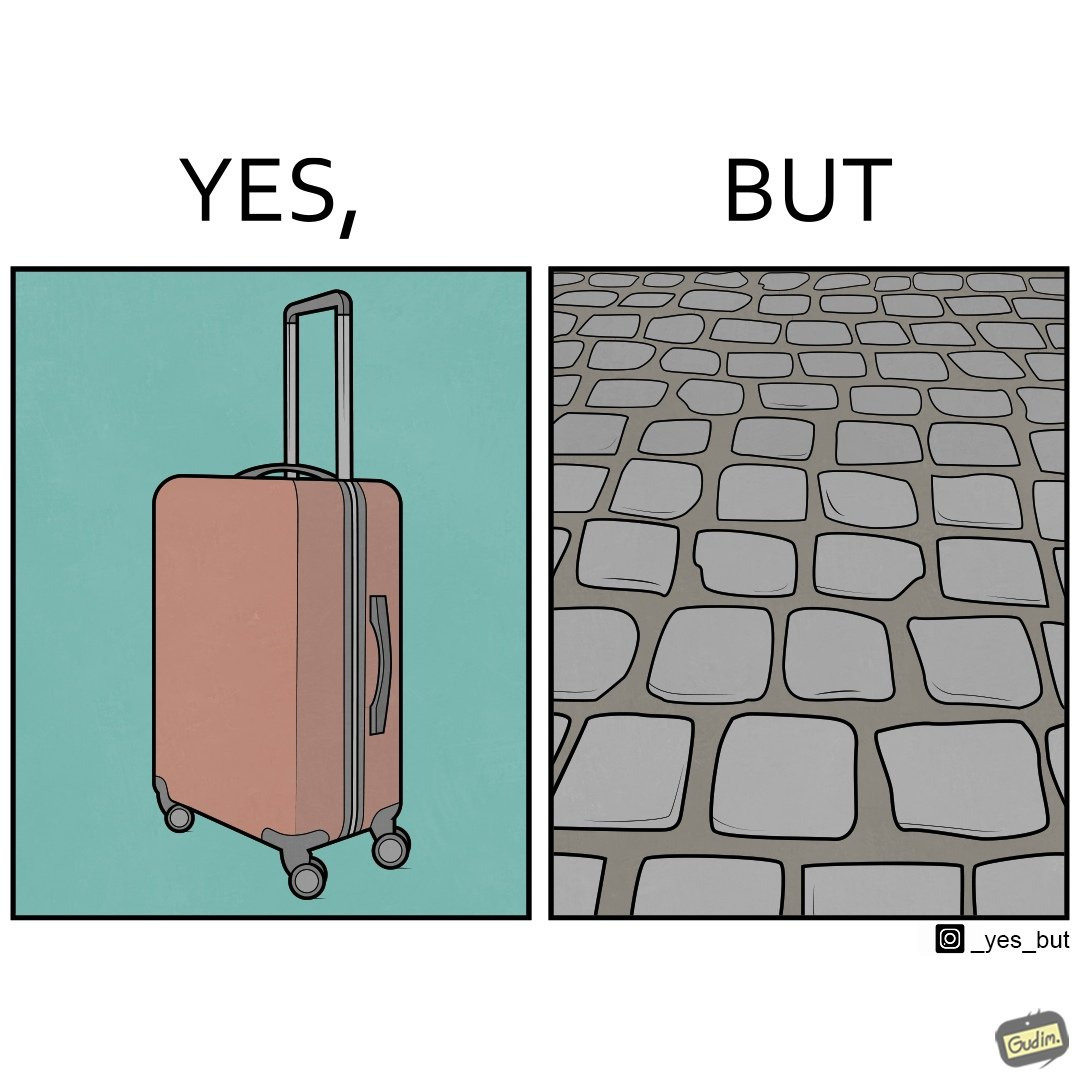Compare the left and right sides of this image. In the left part of the image: it is a trolley luggage bag In the right part of the image: It is a cobblestone road 